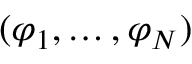<formula> <loc_0><loc_0><loc_500><loc_500>( \varphi _ { 1 } , \dots , \varphi _ { N } )</formula> 